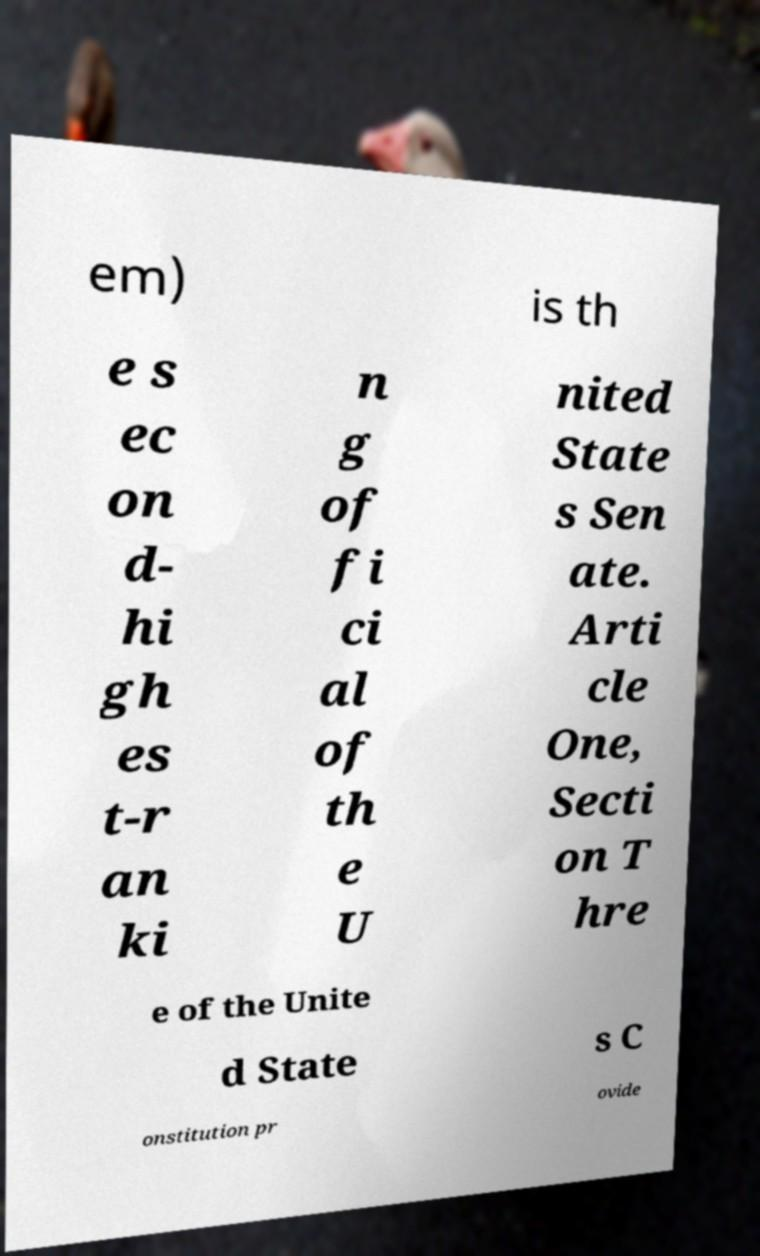I need the written content from this picture converted into text. Can you do that? em) is th e s ec on d- hi gh es t-r an ki n g of fi ci al of th e U nited State s Sen ate. Arti cle One, Secti on T hre e of the Unite d State s C onstitution pr ovide 